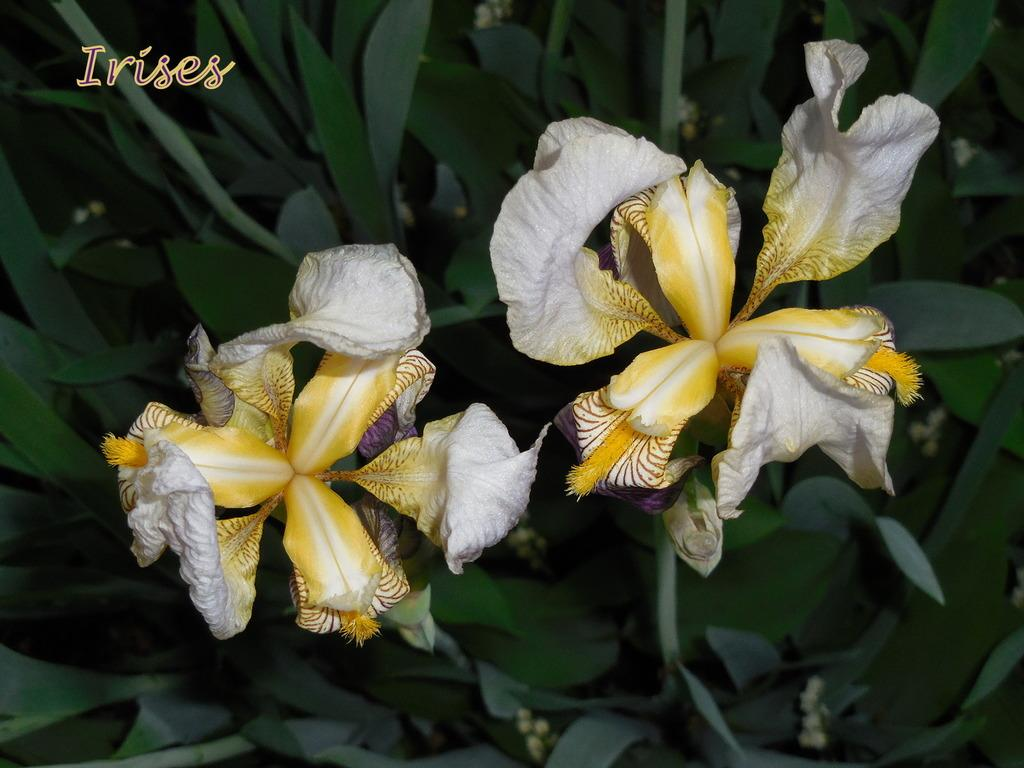What is present in the image? There is a plant in the image. Can you describe the plant in more detail? The plant has two flowers. Is there any text visible in the image? Yes, there is text in the left top corner of the image. What type of feast is being prepared in the image? There is no feast present in the image; it only features a plant with two flowers and text in the left top corner. 